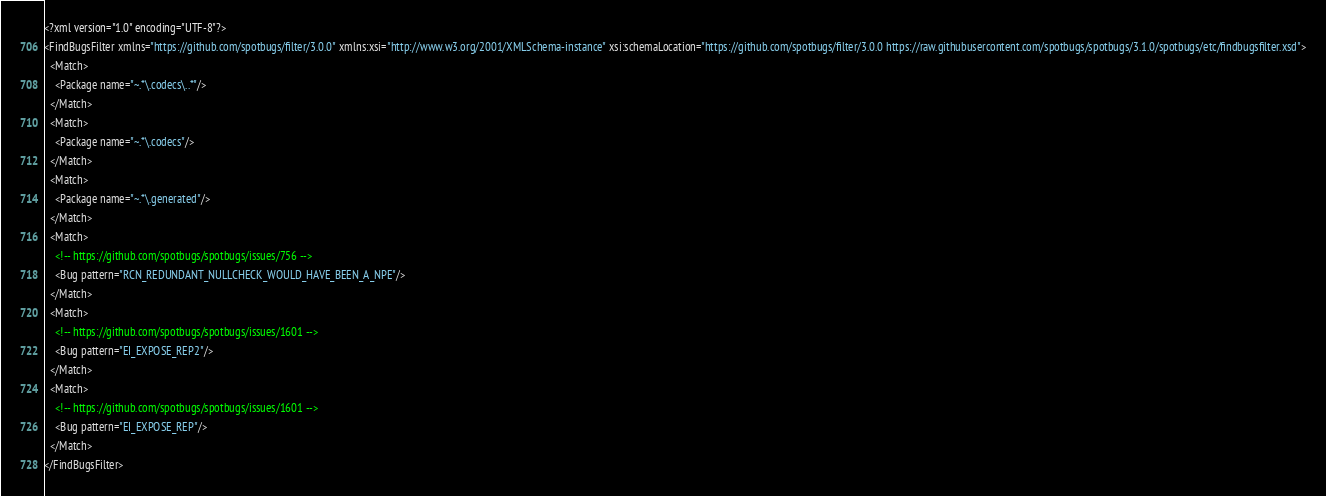<code> <loc_0><loc_0><loc_500><loc_500><_XML_><?xml version="1.0" encoding="UTF-8"?>
<FindBugsFilter xmlns="https://github.com/spotbugs/filter/3.0.0" xmlns:xsi="http://www.w3.org/2001/XMLSchema-instance" xsi:schemaLocation="https://github.com/spotbugs/filter/3.0.0 https://raw.githubusercontent.com/spotbugs/spotbugs/3.1.0/spotbugs/etc/findbugsfilter.xsd">
  <Match>
    <Package name="~.*\.codecs\..*"/>
  </Match>
  <Match>
    <Package name="~.*\.codecs"/>
  </Match>
  <Match>
    <Package name="~.*\.generated"/>
  </Match>
  <Match>
    <!-- https://github.com/spotbugs/spotbugs/issues/756 -->
    <Bug pattern="RCN_REDUNDANT_NULLCHECK_WOULD_HAVE_BEEN_A_NPE"/>
  </Match>
  <Match>
    <!-- https://github.com/spotbugs/spotbugs/issues/1601 -->
    <Bug pattern="EI_EXPOSE_REP2"/>
  </Match>
  <Match>
    <!-- https://github.com/spotbugs/spotbugs/issues/1601 -->
    <Bug pattern="EI_EXPOSE_REP"/>
  </Match>
</FindBugsFilter>
</code> 